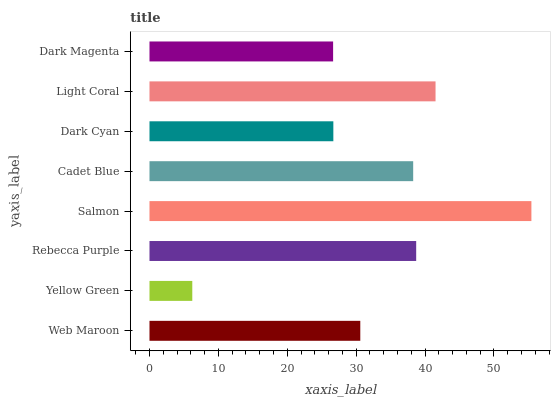Is Yellow Green the minimum?
Answer yes or no. Yes. Is Salmon the maximum?
Answer yes or no. Yes. Is Rebecca Purple the minimum?
Answer yes or no. No. Is Rebecca Purple the maximum?
Answer yes or no. No. Is Rebecca Purple greater than Yellow Green?
Answer yes or no. Yes. Is Yellow Green less than Rebecca Purple?
Answer yes or no. Yes. Is Yellow Green greater than Rebecca Purple?
Answer yes or no. No. Is Rebecca Purple less than Yellow Green?
Answer yes or no. No. Is Cadet Blue the high median?
Answer yes or no. Yes. Is Web Maroon the low median?
Answer yes or no. Yes. Is Yellow Green the high median?
Answer yes or no. No. Is Light Coral the low median?
Answer yes or no. No. 